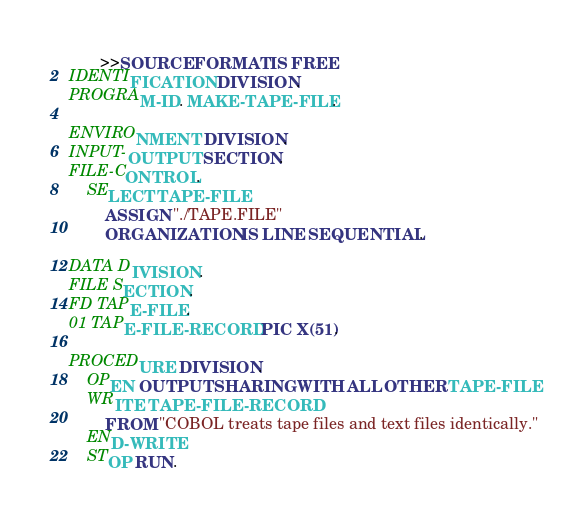Convert code to text. <code><loc_0><loc_0><loc_500><loc_500><_COBOL_>       >>SOURCE FORMAT IS FREE
IDENTIFICATION DIVISION.
PROGRAM-ID. MAKE-TAPE-FILE.

ENVIRONMENT DIVISION.
INPUT-OUTPUT SECTION.
FILE-CONTROL.
    SELECT TAPE-FILE
        ASSIGN "./TAPE.FILE"
        ORGANIZATION IS LINE SEQUENTIAL.

DATA DIVISION.
FILE SECTION.
FD TAPE-FILE.
01 TAPE-FILE-RECORD PIC X(51).

PROCEDURE DIVISION.
    OPEN OUTPUT SHARING WITH ALL OTHER TAPE-FILE
    WRITE TAPE-FILE-RECORD
        FROM "COBOL treats tape files and text files identically."
    END-WRITE
    STOP RUN.
</code> 